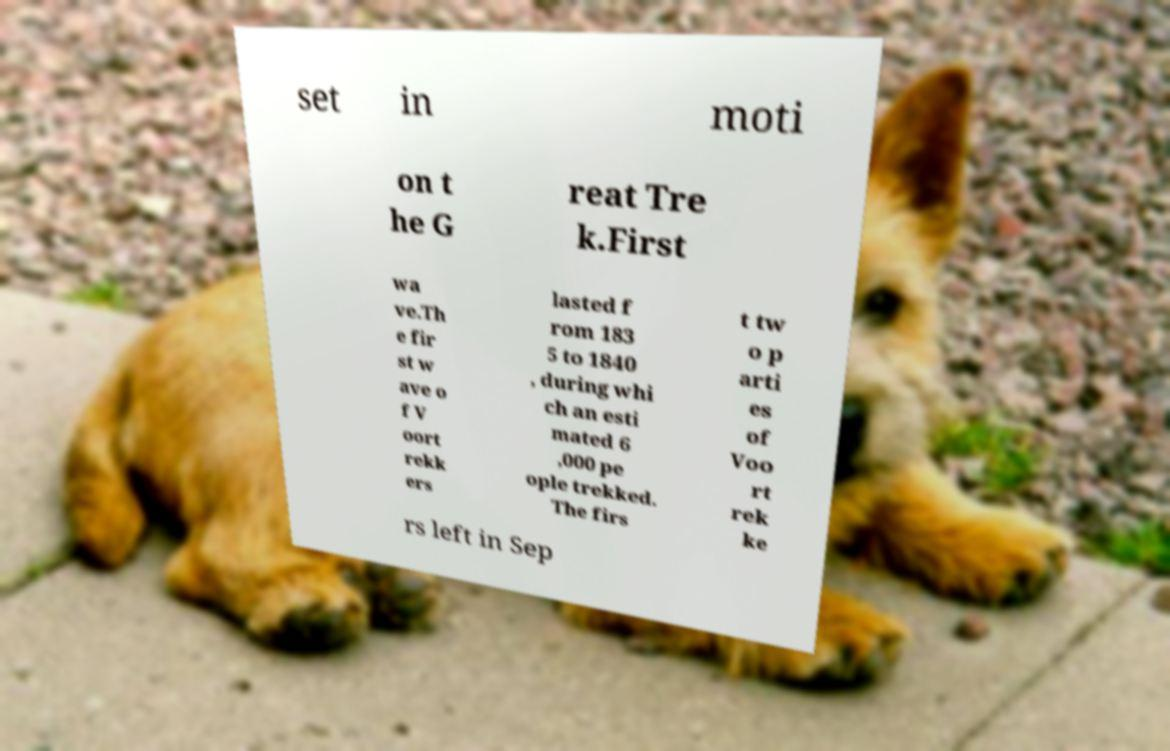Could you extract and type out the text from this image? set in moti on t he G reat Tre k.First wa ve.Th e fir st w ave o f V oort rekk ers lasted f rom 183 5 to 1840 , during whi ch an esti mated 6 ,000 pe ople trekked. The firs t tw o p arti es of Voo rt rek ke rs left in Sep 